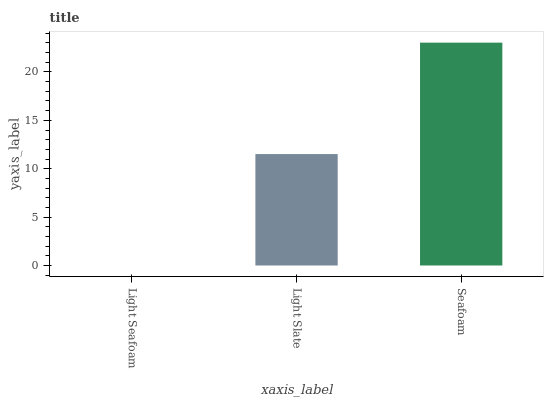Is Light Slate the minimum?
Answer yes or no. No. Is Light Slate the maximum?
Answer yes or no. No. Is Light Slate greater than Light Seafoam?
Answer yes or no. Yes. Is Light Seafoam less than Light Slate?
Answer yes or no. Yes. Is Light Seafoam greater than Light Slate?
Answer yes or no. No. Is Light Slate less than Light Seafoam?
Answer yes or no. No. Is Light Slate the high median?
Answer yes or no. Yes. Is Light Slate the low median?
Answer yes or no. Yes. Is Light Seafoam the high median?
Answer yes or no. No. Is Light Seafoam the low median?
Answer yes or no. No. 